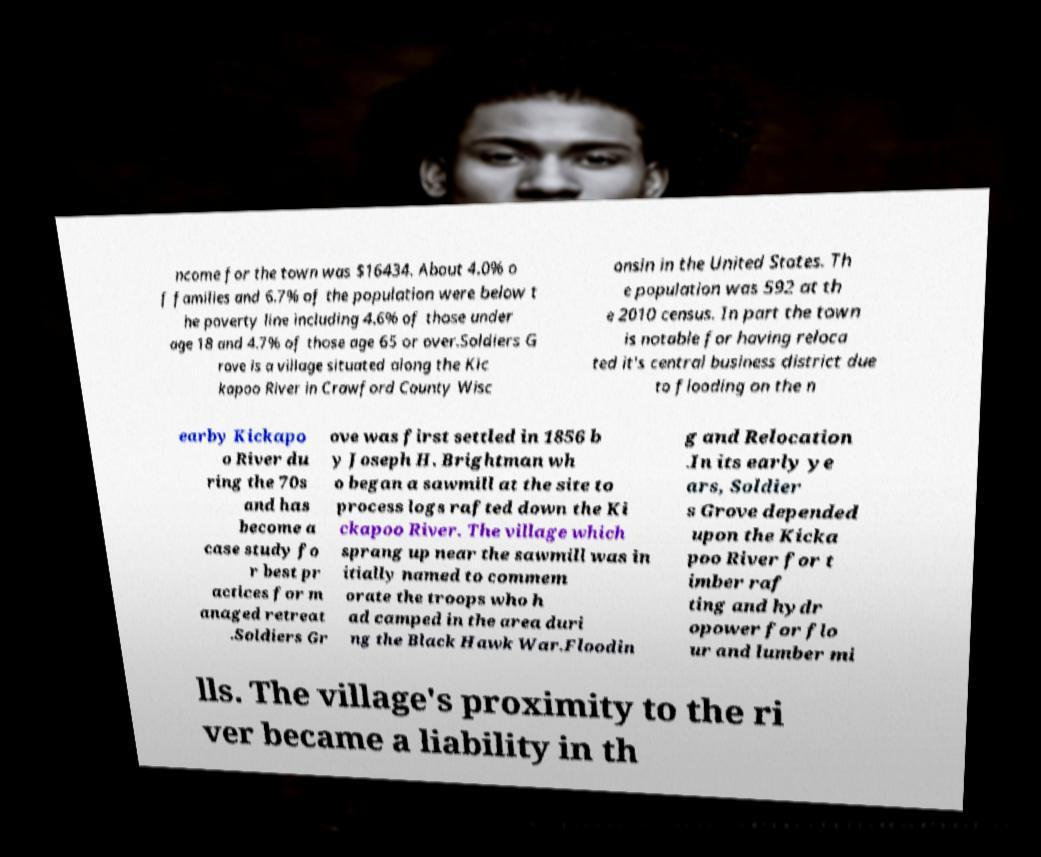Please read and relay the text visible in this image. What does it say? ncome for the town was $16434. About 4.0% o f families and 6.7% of the population were below t he poverty line including 4.6% of those under age 18 and 4.7% of those age 65 or over.Soldiers G rove is a village situated along the Kic kapoo River in Crawford County Wisc onsin in the United States. Th e population was 592 at th e 2010 census. In part the town is notable for having reloca ted it's central business district due to flooding on the n earby Kickapo o River du ring the 70s and has become a case study fo r best pr actices for m anaged retreat .Soldiers Gr ove was first settled in 1856 b y Joseph H. Brightman wh o began a sawmill at the site to process logs rafted down the Ki ckapoo River. The village which sprang up near the sawmill was in itially named to commem orate the troops who h ad camped in the area duri ng the Black Hawk War.Floodin g and Relocation .In its early ye ars, Soldier s Grove depended upon the Kicka poo River for t imber raf ting and hydr opower for flo ur and lumber mi lls. The village's proximity to the ri ver became a liability in th 